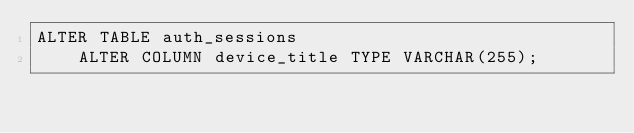Convert code to text. <code><loc_0><loc_0><loc_500><loc_500><_SQL_>ALTER TABLE auth_sessions
    ALTER COLUMN device_title TYPE VARCHAR(255);</code> 